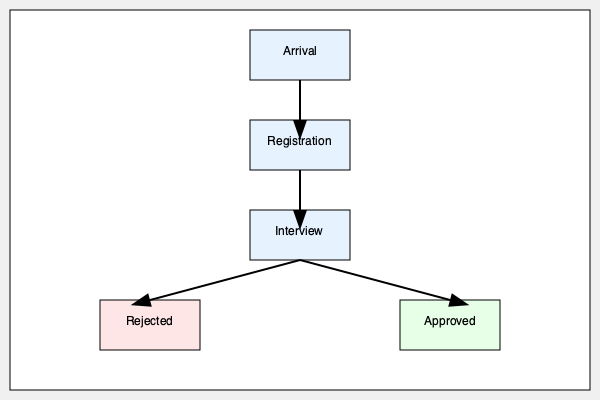In the refugee application process flowchart, which step immediately follows the "Arrival" stage? To answer this question, we need to follow the steps in the flowchart:

1. The flowchart starts with the "Arrival" stage at the top.
2. From "Arrival", there is an arrow pointing downwards to the next stage.
3. This arrow leads to the "Registration" stage.
4. After "Registration", the flowchart continues to "Interview".
5. The "Interview" stage then branches into two possible outcomes: "Rejected" or "Approved".

Therefore, the step that immediately follows the "Arrival" stage in the refugee application process is "Registration".
Answer: Registration 